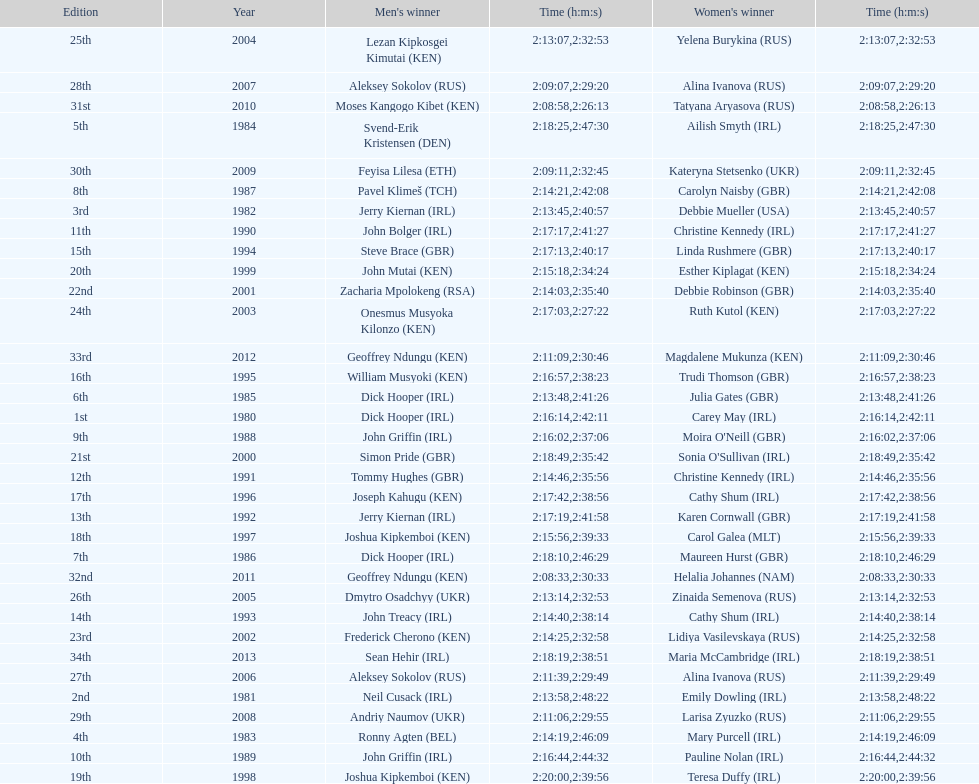Who won at least 3 times in the mens? Dick Hooper (IRL). 